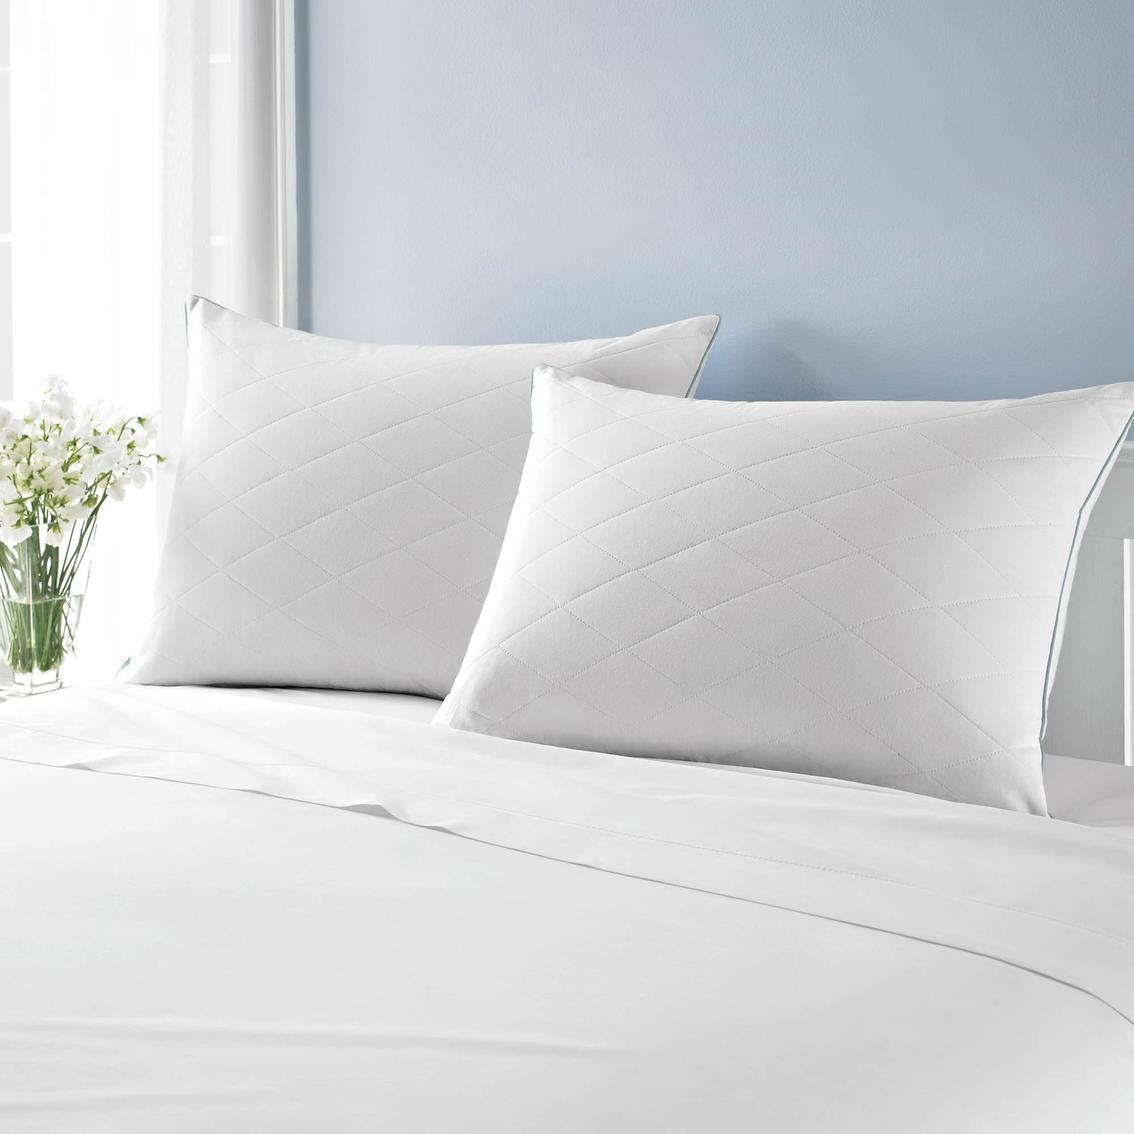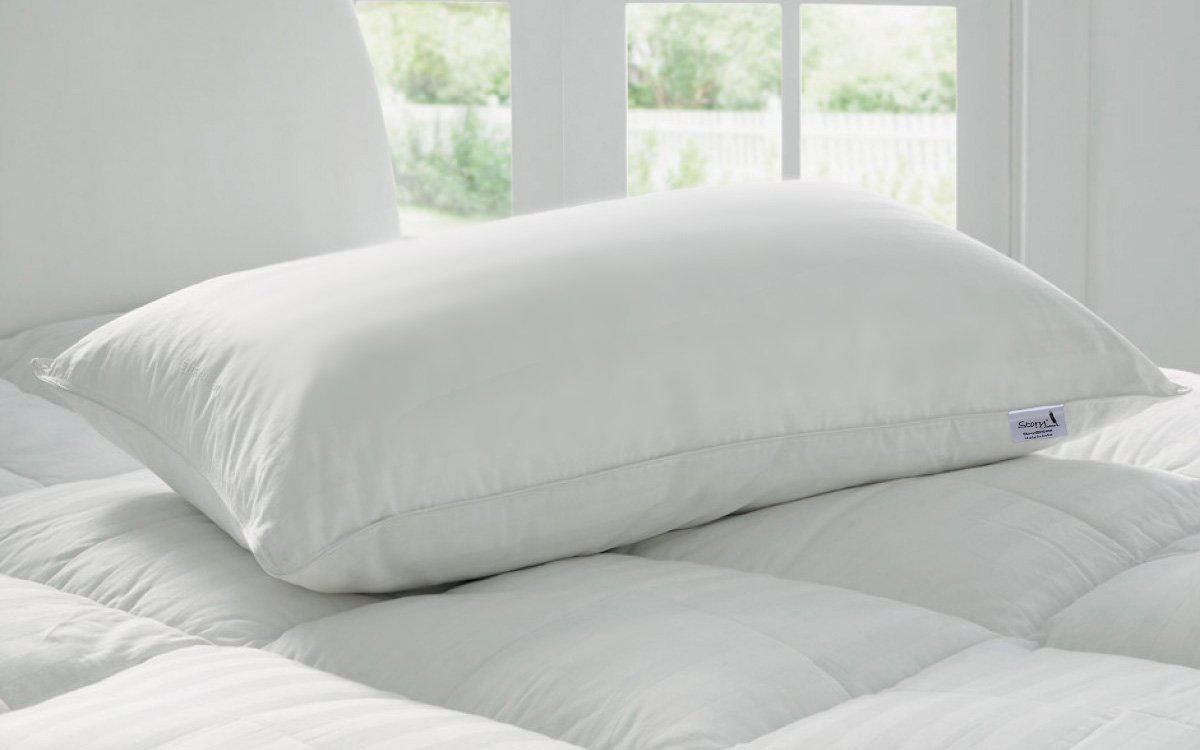The first image is the image on the left, the second image is the image on the right. Given the left and right images, does the statement "The right image contains exactly three white pillows with smooth surfaces arranged overlapping but not stacked vertically." hold true? Answer yes or no. No. The first image is the image on the left, the second image is the image on the right. Considering the images on both sides, is "There are four white pillows on top of a white comforter." valid? Answer yes or no. No. 